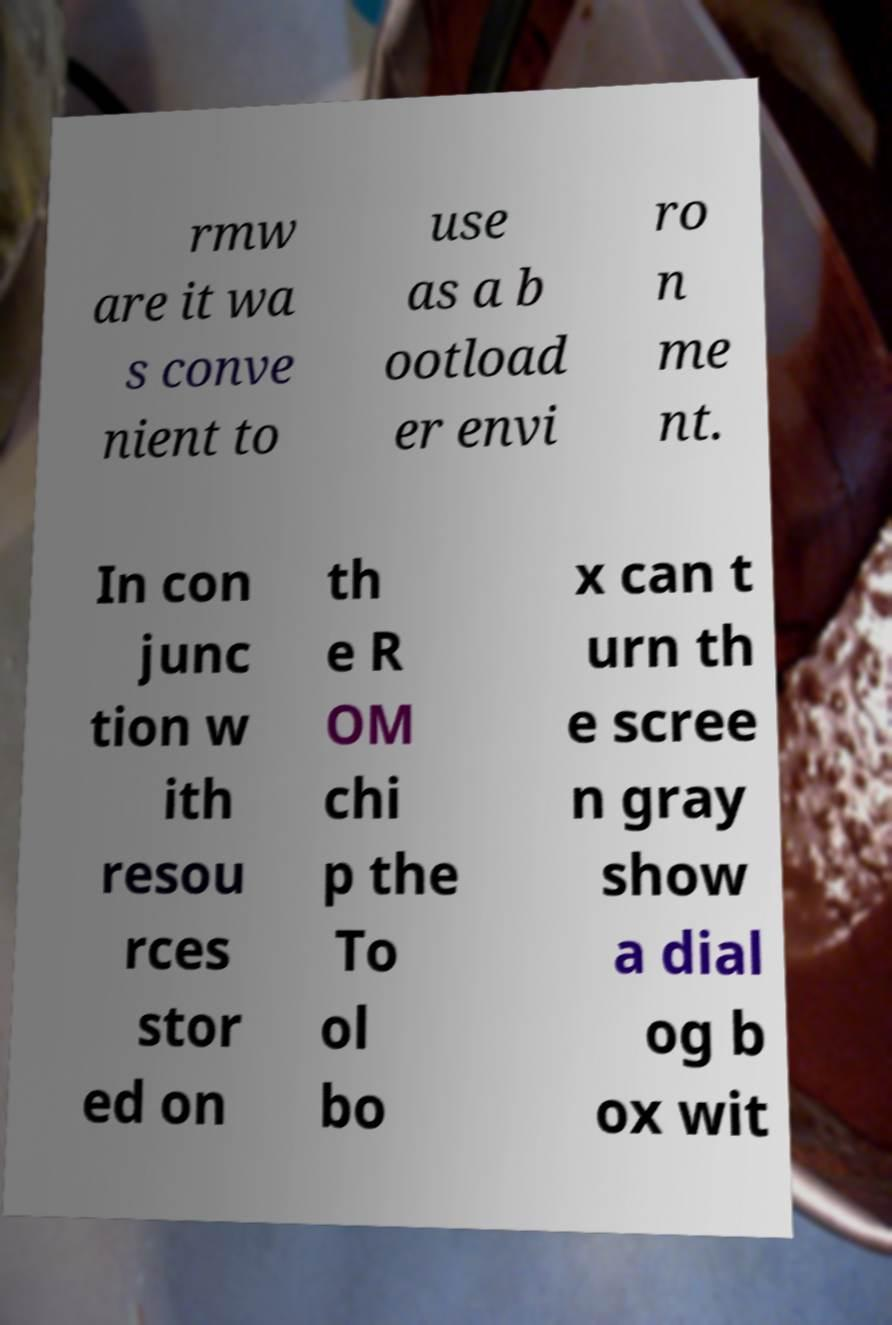Can you accurately transcribe the text from the provided image for me? rmw are it wa s conve nient to use as a b ootload er envi ro n me nt. In con junc tion w ith resou rces stor ed on th e R OM chi p the To ol bo x can t urn th e scree n gray show a dial og b ox wit 